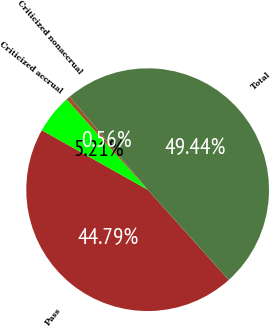Convert chart. <chart><loc_0><loc_0><loc_500><loc_500><pie_chart><fcel>Pass<fcel>Criticized accrual<fcel>Criticized nonaccrual<fcel>Total<nl><fcel>44.79%<fcel>5.21%<fcel>0.56%<fcel>49.44%<nl></chart> 